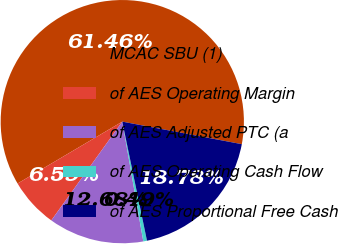Convert chart. <chart><loc_0><loc_0><loc_500><loc_500><pie_chart><fcel>MCAC SBU (1)<fcel>of AES Operating Margin<fcel>of AES Adjusted PTC (a<fcel>of AES Operating Cash Flow<fcel>of AES Proportional Free Cash<nl><fcel>61.46%<fcel>6.59%<fcel>12.68%<fcel>0.49%<fcel>18.78%<nl></chart> 